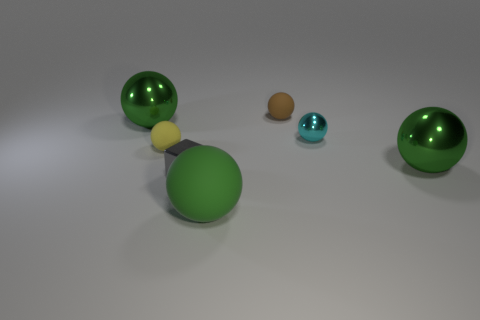Do the cyan sphere and the gray cube have the same size?
Keep it short and to the point. Yes. What number of other objects are the same size as the cyan thing?
Provide a succinct answer. 3. There is a big metal thing on the right side of the small gray cube that is to the right of the large sphere that is left of the large green matte ball; what shape is it?
Your response must be concise. Sphere. What number of things are either balls on the left side of the small yellow sphere or spheres on the left side of the gray block?
Your answer should be very brief. 2. There is a cyan sphere that is behind the tiny rubber sphere on the left side of the brown object; what is its size?
Provide a succinct answer. Small. There is a large shiny ball on the left side of the tiny yellow rubber thing; does it have the same color as the large matte thing?
Give a very brief answer. Yes. Is there a tiny cyan object of the same shape as the brown object?
Your answer should be very brief. Yes. What color is the metallic block that is the same size as the brown thing?
Your response must be concise. Gray. How big is the green sphere that is to the right of the brown matte ball?
Keep it short and to the point. Large. Are there any large green objects in front of the metallic ball on the left side of the cyan thing?
Your answer should be very brief. Yes. 